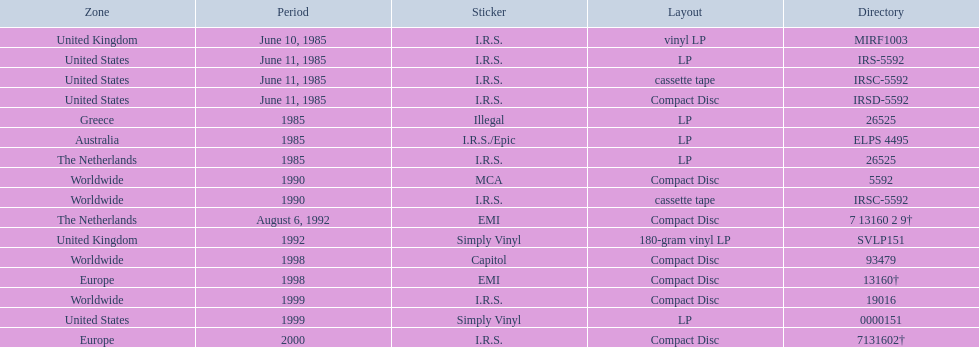Which country or region had the most releases? Worldwide. 